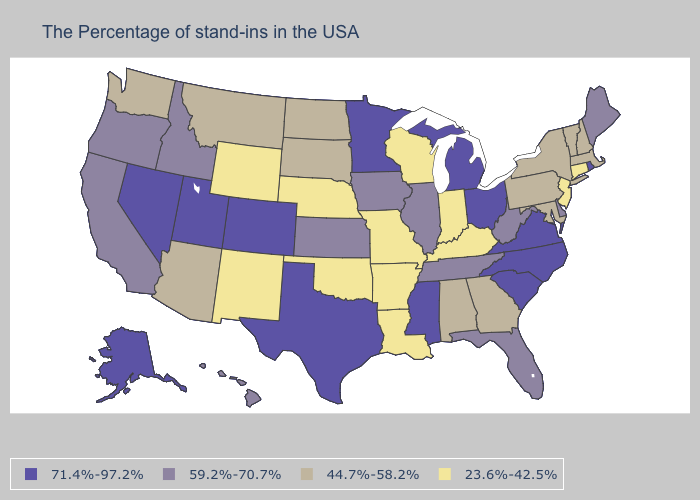Name the states that have a value in the range 71.4%-97.2%?
Concise answer only. Rhode Island, Virginia, North Carolina, South Carolina, Ohio, Michigan, Mississippi, Minnesota, Texas, Colorado, Utah, Nevada, Alaska. Which states have the lowest value in the USA?
Keep it brief. Connecticut, New Jersey, Kentucky, Indiana, Wisconsin, Louisiana, Missouri, Arkansas, Nebraska, Oklahoma, Wyoming, New Mexico. Name the states that have a value in the range 59.2%-70.7%?
Short answer required. Maine, Delaware, West Virginia, Florida, Tennessee, Illinois, Iowa, Kansas, Idaho, California, Oregon, Hawaii. What is the value of Arizona?
Answer briefly. 44.7%-58.2%. Name the states that have a value in the range 59.2%-70.7%?
Give a very brief answer. Maine, Delaware, West Virginia, Florida, Tennessee, Illinois, Iowa, Kansas, Idaho, California, Oregon, Hawaii. What is the lowest value in the USA?
Concise answer only. 23.6%-42.5%. What is the highest value in the South ?
Answer briefly. 71.4%-97.2%. Which states have the lowest value in the MidWest?
Keep it brief. Indiana, Wisconsin, Missouri, Nebraska. Does the first symbol in the legend represent the smallest category?
Short answer required. No. What is the value of North Dakota?
Concise answer only. 44.7%-58.2%. Does the map have missing data?
Concise answer only. No. What is the highest value in the MidWest ?
Be succinct. 71.4%-97.2%. Does Michigan have the same value as Minnesota?
Answer briefly. Yes. Among the states that border Arkansas , which have the lowest value?
Be succinct. Louisiana, Missouri, Oklahoma. What is the value of California?
Short answer required. 59.2%-70.7%. 